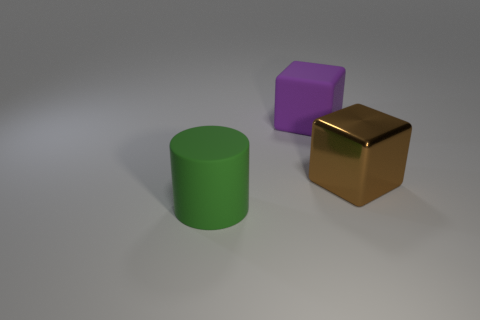Could you describe the texture and color of the small purple block in the image? The small purple block appears to have a smooth texture with a matte finish. Its color is a moderate shade of purple. 